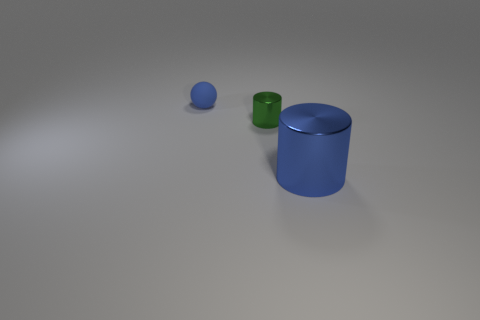Add 1 big blue metallic cylinders. How many objects exist? 4 Subtract all cylinders. How many objects are left? 1 Subtract all blue cubes. How many green balls are left? 0 Add 1 matte spheres. How many matte spheres exist? 2 Subtract all blue cylinders. How many cylinders are left? 1 Subtract 0 brown cylinders. How many objects are left? 3 Subtract all gray spheres. Subtract all gray cylinders. How many spheres are left? 1 Subtract all blue balls. Subtract all small green metal cylinders. How many objects are left? 1 Add 1 tiny blue rubber objects. How many tiny blue rubber objects are left? 2 